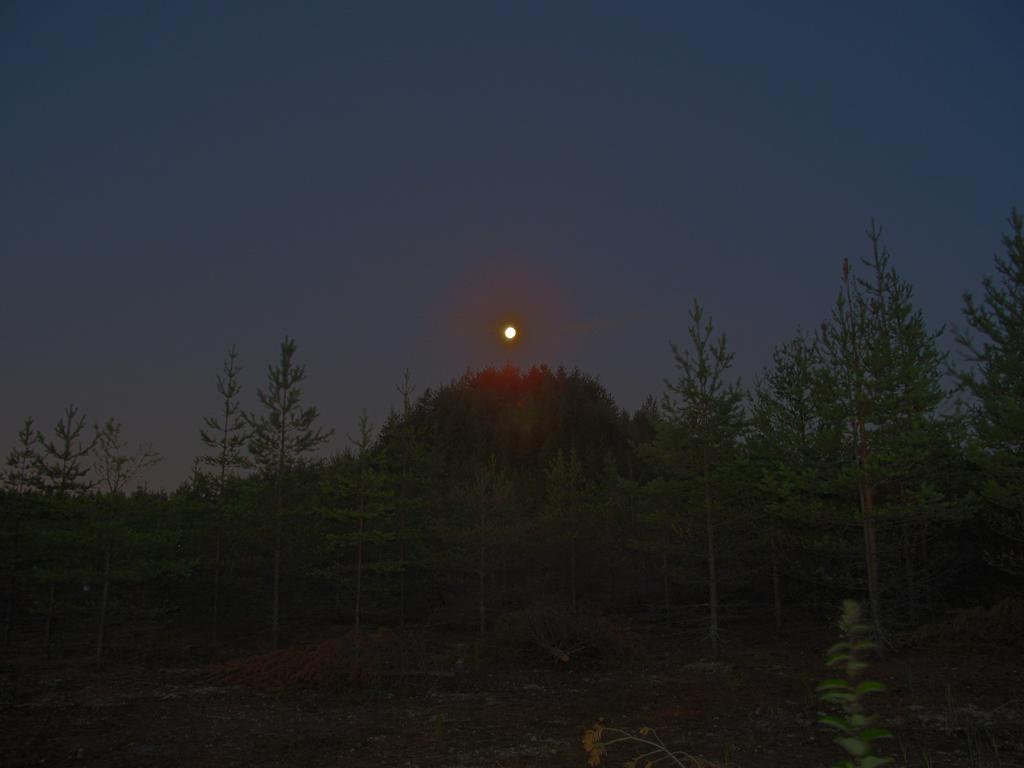What can be seen at the bottom of the image? The ground is visible in the image. What type of vegetation is present in the image? There are trees in the image. What is visible in the distance in the image? The sky is visible in the background of the image. What does the hand smell like in the image? There is no hand present in the image, so it is not possible to determine what it might smell like. 